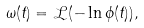Convert formula to latex. <formula><loc_0><loc_0><loc_500><loc_500>\omega ( t ) = \mathcal { L } ( - \ln \phi ( t ) ) ,</formula> 